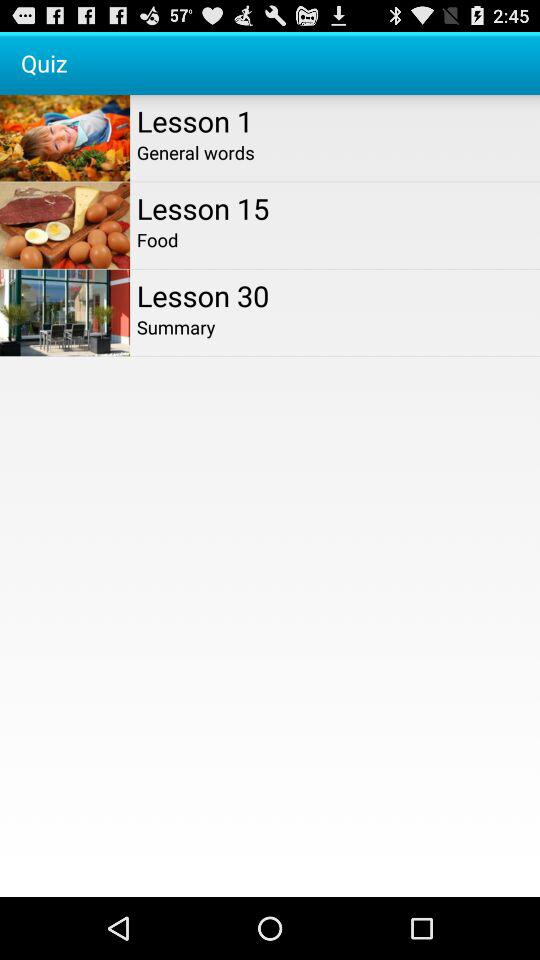What is the total number of lesson?
When the provided information is insufficient, respond with <no answer>. <no answer> 